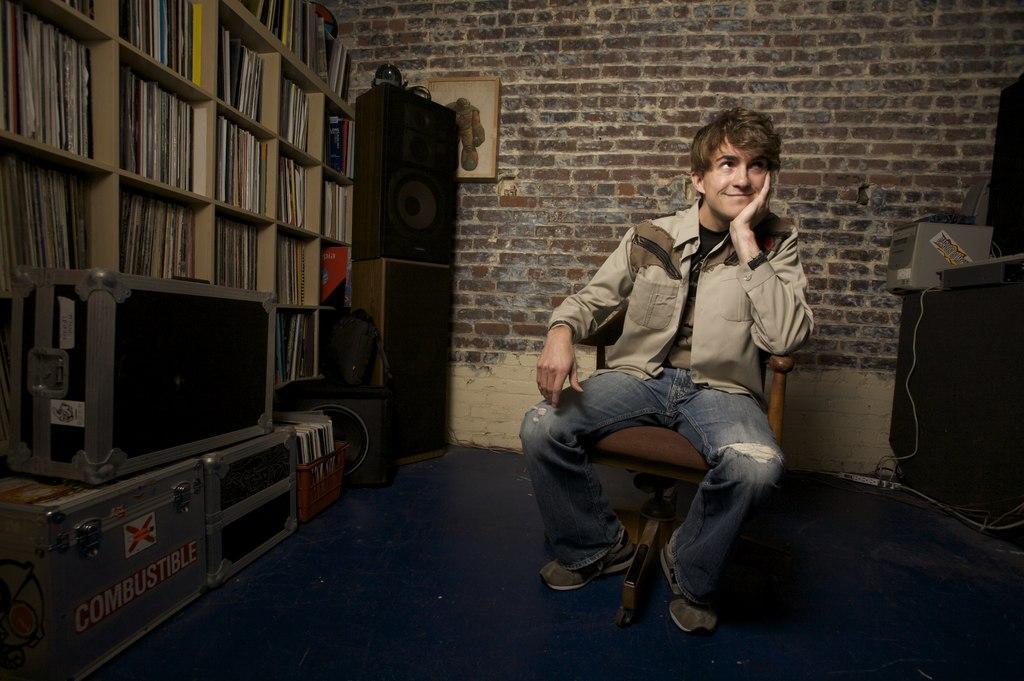Please provide a concise description of this image. In this picture, there is a man sitting on the chair. He is wearing a brown jacket and blue jeans. Towards the left, there is a shelf filled with the books. Before it, there are trunks and sound speakers. In the background, there is a wall with a frame. Towards the right, there are some objects. 